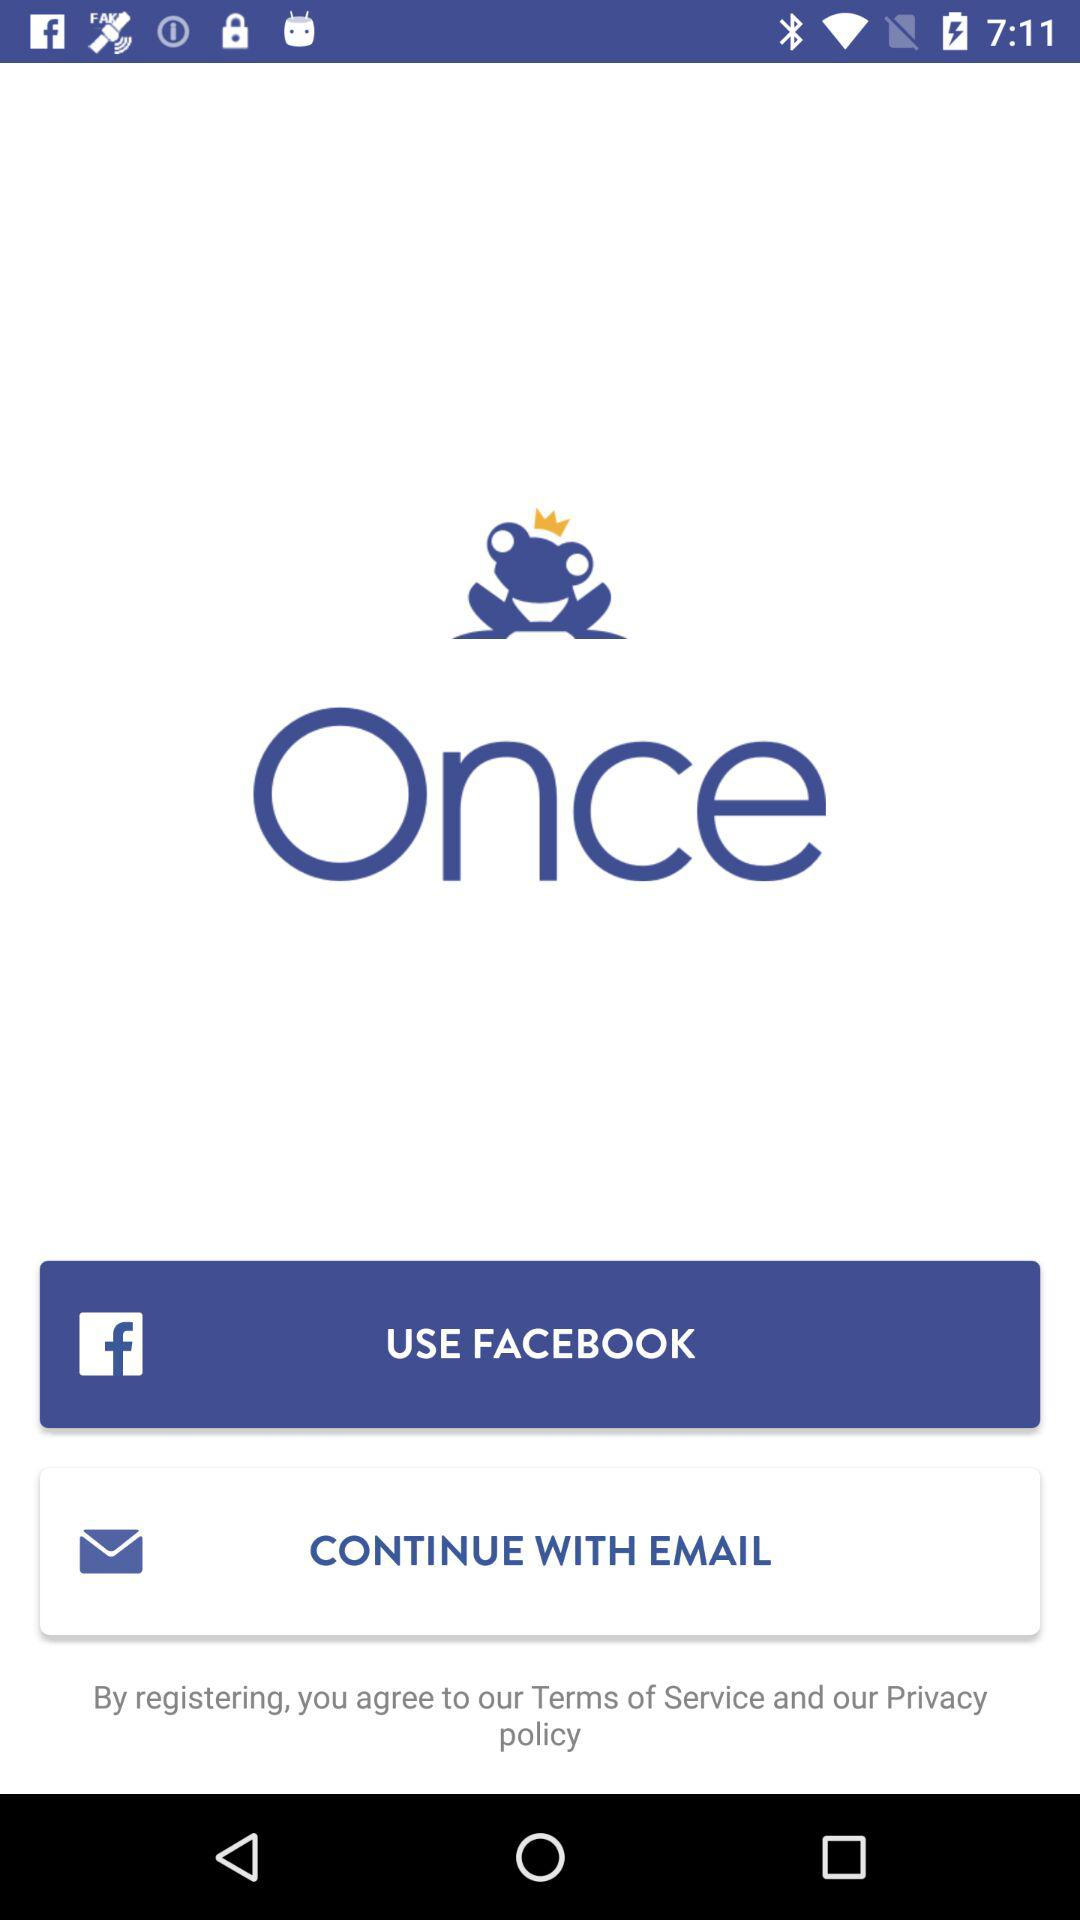Which application is asking for permissions?
When the provided information is insufficient, respond with <no answer>. <no answer> 